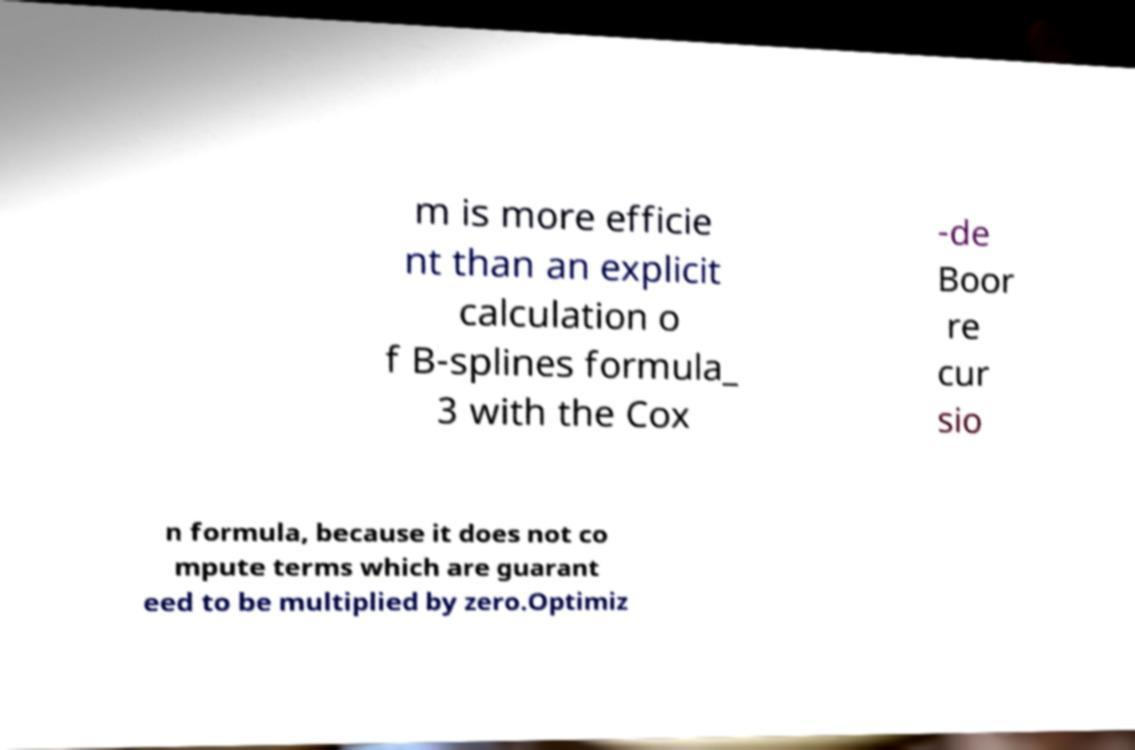I need the written content from this picture converted into text. Can you do that? m is more efficie nt than an explicit calculation o f B-splines formula_ 3 with the Cox -de Boor re cur sio n formula, because it does not co mpute terms which are guarant eed to be multiplied by zero.Optimiz 